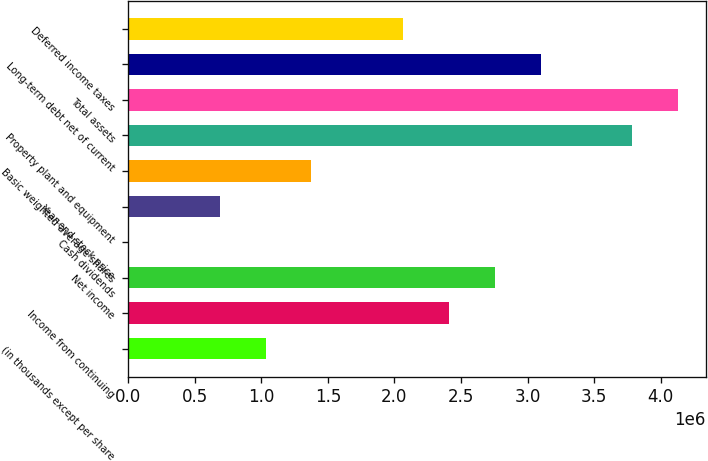<chart> <loc_0><loc_0><loc_500><loc_500><bar_chart><fcel>(in thousands except per share<fcel>Income from continuing<fcel>Net income<fcel>Cash dividends<fcel>Year-end stock price<fcel>Basic weighted average shares<fcel>Property plant and equipment<fcel>Total assets<fcel>Long-term debt net of current<fcel>Deferred income taxes<nl><fcel>1.03295e+06<fcel>2.41022e+06<fcel>2.75454e+06<fcel>0.2<fcel>688634<fcel>1.37727e+06<fcel>3.78749e+06<fcel>4.13181e+06<fcel>3.09885e+06<fcel>2.0659e+06<nl></chart> 